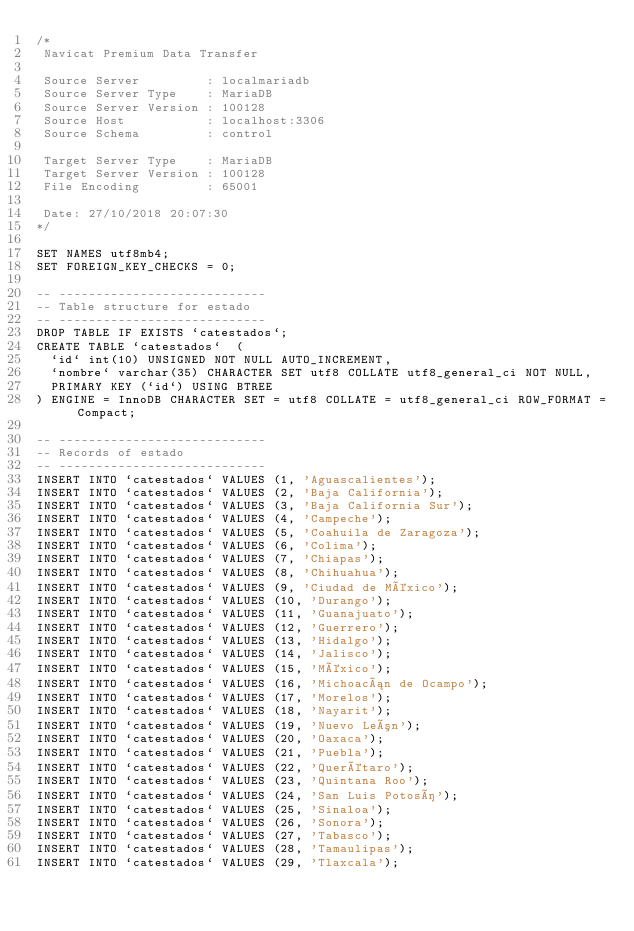<code> <loc_0><loc_0><loc_500><loc_500><_SQL_>/*
 Navicat Premium Data Transfer

 Source Server         : localmariadb
 Source Server Type    : MariaDB
 Source Server Version : 100128
 Source Host           : localhost:3306
 Source Schema         : control

 Target Server Type    : MariaDB
 Target Server Version : 100128
 File Encoding         : 65001

 Date: 27/10/2018 20:07:30
*/

SET NAMES utf8mb4;
SET FOREIGN_KEY_CHECKS = 0;

-- ----------------------------
-- Table structure for estado
-- ----------------------------
DROP TABLE IF EXISTS `catestados`;
CREATE TABLE `catestados`  (
  `id` int(10) UNSIGNED NOT NULL AUTO_INCREMENT,
  `nombre` varchar(35) CHARACTER SET utf8 COLLATE utf8_general_ci NOT NULL,
  PRIMARY KEY (`id`) USING BTREE
) ENGINE = InnoDB CHARACTER SET = utf8 COLLATE = utf8_general_ci ROW_FORMAT = Compact;

-- ----------------------------
-- Records of estado
-- ----------------------------
INSERT INTO `catestados` VALUES (1, 'Aguascalientes');
INSERT INTO `catestados` VALUES (2, 'Baja California');
INSERT INTO `catestados` VALUES (3, 'Baja California Sur');
INSERT INTO `catestados` VALUES (4, 'Campeche');
INSERT INTO `catestados` VALUES (5, 'Coahuila de Zaragoza');
INSERT INTO `catestados` VALUES (6, 'Colima');
INSERT INTO `catestados` VALUES (7, 'Chiapas');
INSERT INTO `catestados` VALUES (8, 'Chihuahua');
INSERT INTO `catestados` VALUES (9, 'Ciudad de México');
INSERT INTO `catestados` VALUES (10, 'Durango');
INSERT INTO `catestados` VALUES (11, 'Guanajuato');
INSERT INTO `catestados` VALUES (12, 'Guerrero');
INSERT INTO `catestados` VALUES (13, 'Hidalgo');
INSERT INTO `catestados` VALUES (14, 'Jalisco');
INSERT INTO `catestados` VALUES (15, 'México');
INSERT INTO `catestados` VALUES (16, 'Michoacán de Ocampo');
INSERT INTO `catestados` VALUES (17, 'Morelos');
INSERT INTO `catestados` VALUES (18, 'Nayarit');
INSERT INTO `catestados` VALUES (19, 'Nuevo León');
INSERT INTO `catestados` VALUES (20, 'Oaxaca');
INSERT INTO `catestados` VALUES (21, 'Puebla');
INSERT INTO `catestados` VALUES (22, 'Querétaro');
INSERT INTO `catestados` VALUES (23, 'Quintana Roo');
INSERT INTO `catestados` VALUES (24, 'San Luis Potosí');
INSERT INTO `catestados` VALUES (25, 'Sinaloa');
INSERT INTO `catestados` VALUES (26, 'Sonora');
INSERT INTO `catestados` VALUES (27, 'Tabasco');
INSERT INTO `catestados` VALUES (28, 'Tamaulipas');
INSERT INTO `catestados` VALUES (29, 'Tlaxcala');</code> 